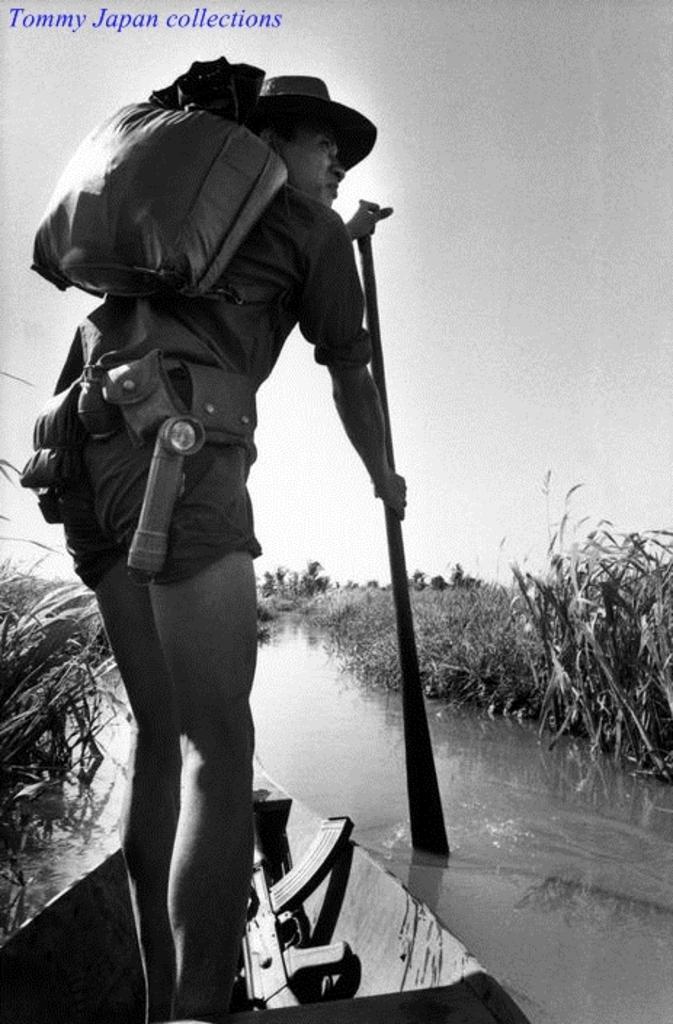In one or two sentences, can you explain what this image depicts? In the foreground of this black and white image, there is a man wearing hat and backpack is holding a paddle and standing on a boat. We can also see a gun on the boat. In the background, there is water, grass and the sky. 